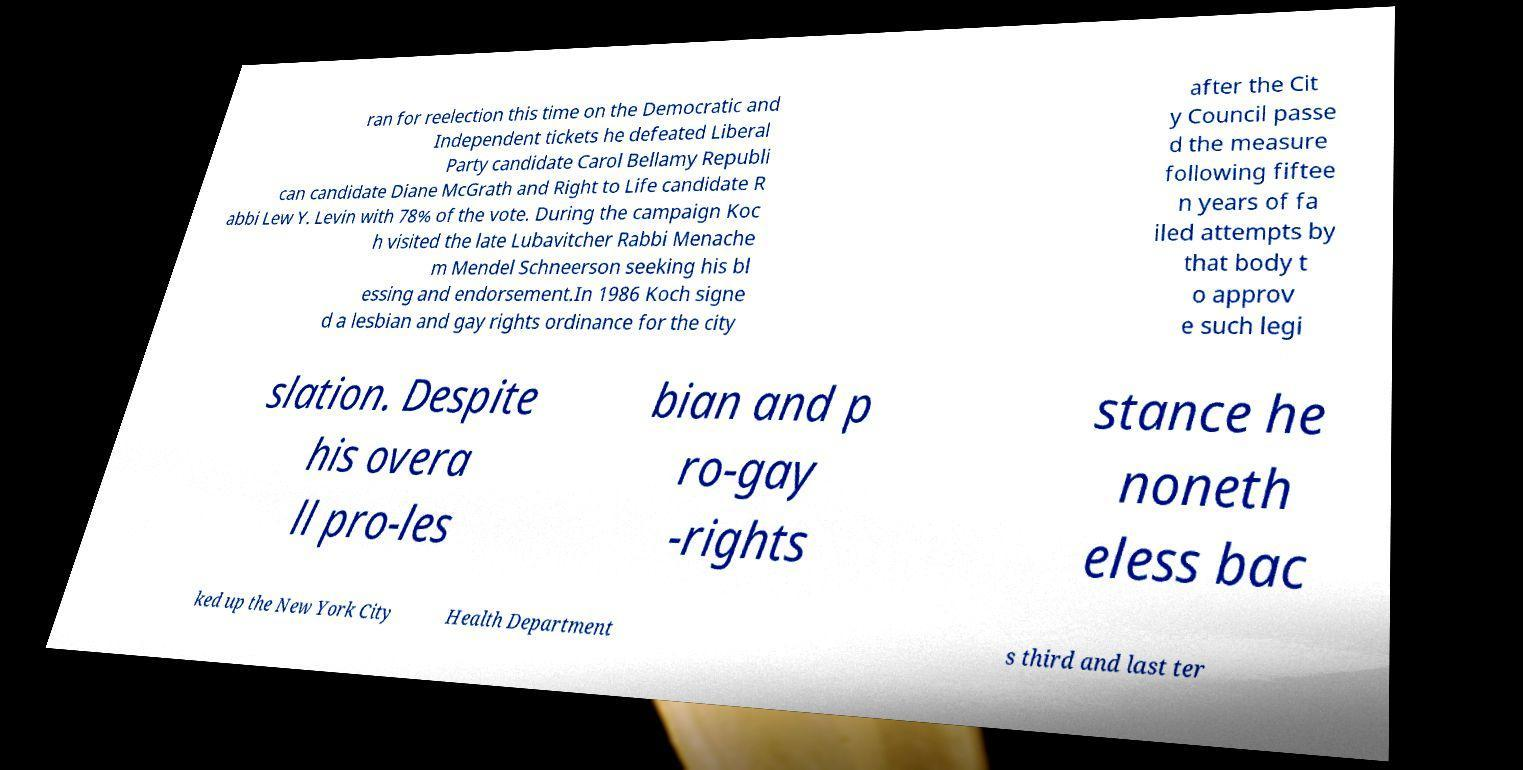Can you accurately transcribe the text from the provided image for me? ran for reelection this time on the Democratic and Independent tickets he defeated Liberal Party candidate Carol Bellamy Republi can candidate Diane McGrath and Right to Life candidate R abbi Lew Y. Levin with 78% of the vote. During the campaign Koc h visited the late Lubavitcher Rabbi Menache m Mendel Schneerson seeking his bl essing and endorsement.In 1986 Koch signe d a lesbian and gay rights ordinance for the city after the Cit y Council passe d the measure following fiftee n years of fa iled attempts by that body t o approv e such legi slation. Despite his overa ll pro-les bian and p ro-gay -rights stance he noneth eless bac ked up the New York City Health Department s third and last ter 